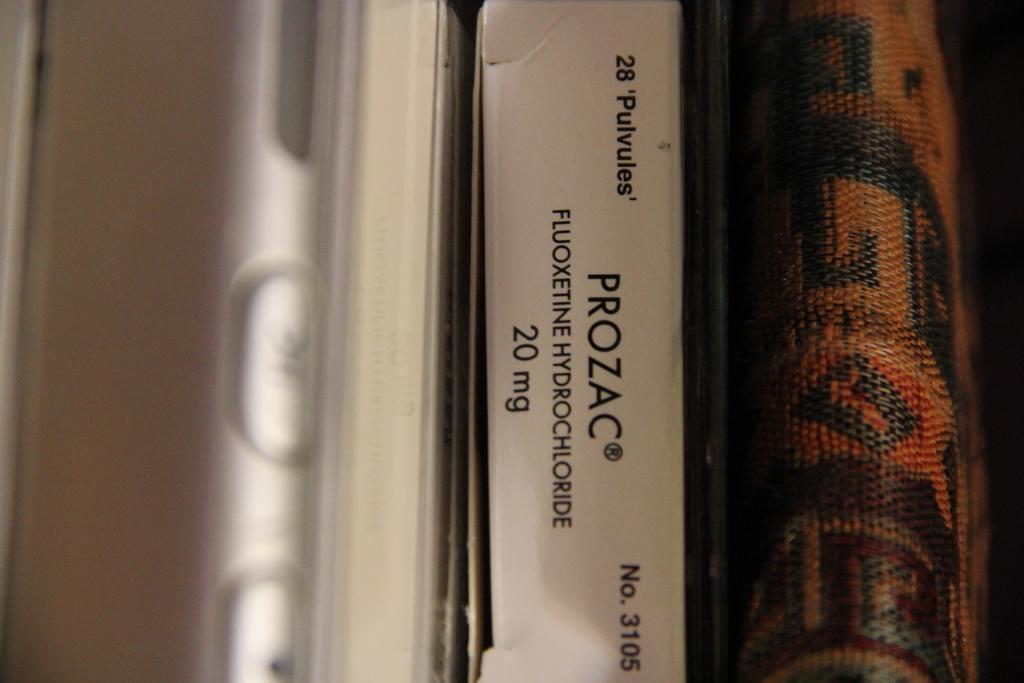<image>
Share a concise interpretation of the image provided. A 20mg box of Prozac next to a braided book 